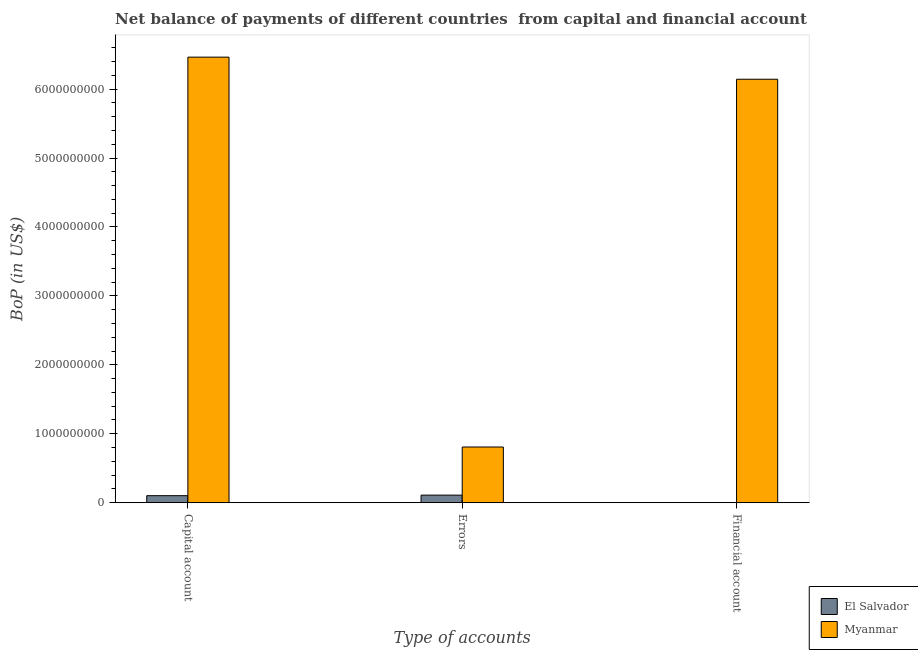Are the number of bars on each tick of the X-axis equal?
Offer a very short reply. No. How many bars are there on the 2nd tick from the left?
Offer a terse response. 2. How many bars are there on the 2nd tick from the right?
Your answer should be very brief. 2. What is the label of the 3rd group of bars from the left?
Your answer should be compact. Financial account. What is the amount of net capital account in El Salvador?
Make the answer very short. 1.01e+08. Across all countries, what is the maximum amount of errors?
Your response must be concise. 8.07e+08. Across all countries, what is the minimum amount of errors?
Make the answer very short. 1.09e+08. In which country was the amount of net capital account maximum?
Your answer should be compact. Myanmar. What is the total amount of financial account in the graph?
Your answer should be compact. 6.14e+09. What is the difference between the amount of net capital account in El Salvador and that in Myanmar?
Provide a short and direct response. -6.36e+09. What is the difference between the amount of financial account in El Salvador and the amount of errors in Myanmar?
Keep it short and to the point. -8.07e+08. What is the average amount of net capital account per country?
Keep it short and to the point. 3.28e+09. What is the difference between the amount of financial account and amount of net capital account in Myanmar?
Offer a very short reply. -3.20e+08. What is the ratio of the amount of net capital account in El Salvador to that in Myanmar?
Your answer should be very brief. 0.02. Is the amount of errors in Myanmar less than that in El Salvador?
Provide a succinct answer. No. What is the difference between the highest and the second highest amount of errors?
Give a very brief answer. 6.98e+08. What is the difference between the highest and the lowest amount of financial account?
Your response must be concise. 6.14e+09. In how many countries, is the amount of errors greater than the average amount of errors taken over all countries?
Ensure brevity in your answer.  1. Is the sum of the amount of errors in Myanmar and El Salvador greater than the maximum amount of net capital account across all countries?
Provide a succinct answer. No. Is it the case that in every country, the sum of the amount of net capital account and amount of errors is greater than the amount of financial account?
Ensure brevity in your answer.  Yes. How many bars are there?
Your response must be concise. 5. What is the difference between two consecutive major ticks on the Y-axis?
Give a very brief answer. 1.00e+09. Are the values on the major ticks of Y-axis written in scientific E-notation?
Offer a very short reply. No. Does the graph contain grids?
Offer a terse response. No. Where does the legend appear in the graph?
Your answer should be compact. Bottom right. How are the legend labels stacked?
Your answer should be compact. Vertical. What is the title of the graph?
Your answer should be compact. Net balance of payments of different countries  from capital and financial account. What is the label or title of the X-axis?
Keep it short and to the point. Type of accounts. What is the label or title of the Y-axis?
Your response must be concise. BoP (in US$). What is the BoP (in US$) in El Salvador in Capital account?
Offer a very short reply. 1.01e+08. What is the BoP (in US$) in Myanmar in Capital account?
Offer a terse response. 6.46e+09. What is the BoP (in US$) in El Salvador in Errors?
Provide a short and direct response. 1.09e+08. What is the BoP (in US$) of Myanmar in Errors?
Your answer should be very brief. 8.07e+08. What is the BoP (in US$) of Myanmar in Financial account?
Ensure brevity in your answer.  6.14e+09. Across all Type of accounts, what is the maximum BoP (in US$) of El Salvador?
Offer a very short reply. 1.09e+08. Across all Type of accounts, what is the maximum BoP (in US$) of Myanmar?
Offer a terse response. 6.46e+09. Across all Type of accounts, what is the minimum BoP (in US$) in El Salvador?
Make the answer very short. 0. Across all Type of accounts, what is the minimum BoP (in US$) of Myanmar?
Make the answer very short. 8.07e+08. What is the total BoP (in US$) in El Salvador in the graph?
Your response must be concise. 2.10e+08. What is the total BoP (in US$) of Myanmar in the graph?
Offer a terse response. 1.34e+1. What is the difference between the BoP (in US$) of El Salvador in Capital account and that in Errors?
Offer a terse response. -8.09e+06. What is the difference between the BoP (in US$) in Myanmar in Capital account and that in Errors?
Provide a short and direct response. 5.66e+09. What is the difference between the BoP (in US$) in Myanmar in Capital account and that in Financial account?
Provide a succinct answer. 3.20e+08. What is the difference between the BoP (in US$) of Myanmar in Errors and that in Financial account?
Your answer should be compact. -5.34e+09. What is the difference between the BoP (in US$) of El Salvador in Capital account and the BoP (in US$) of Myanmar in Errors?
Your answer should be very brief. -7.06e+08. What is the difference between the BoP (in US$) of El Salvador in Capital account and the BoP (in US$) of Myanmar in Financial account?
Make the answer very short. -6.04e+09. What is the difference between the BoP (in US$) of El Salvador in Errors and the BoP (in US$) of Myanmar in Financial account?
Provide a short and direct response. -6.03e+09. What is the average BoP (in US$) of El Salvador per Type of accounts?
Ensure brevity in your answer.  7.01e+07. What is the average BoP (in US$) of Myanmar per Type of accounts?
Keep it short and to the point. 4.47e+09. What is the difference between the BoP (in US$) of El Salvador and BoP (in US$) of Myanmar in Capital account?
Ensure brevity in your answer.  -6.36e+09. What is the difference between the BoP (in US$) in El Salvador and BoP (in US$) in Myanmar in Errors?
Provide a succinct answer. -6.98e+08. What is the ratio of the BoP (in US$) in El Salvador in Capital account to that in Errors?
Keep it short and to the point. 0.93. What is the ratio of the BoP (in US$) in Myanmar in Capital account to that in Errors?
Your answer should be very brief. 8.01. What is the ratio of the BoP (in US$) of Myanmar in Capital account to that in Financial account?
Your response must be concise. 1.05. What is the ratio of the BoP (in US$) of Myanmar in Errors to that in Financial account?
Offer a very short reply. 0.13. What is the difference between the highest and the second highest BoP (in US$) in Myanmar?
Offer a very short reply. 3.20e+08. What is the difference between the highest and the lowest BoP (in US$) in El Salvador?
Ensure brevity in your answer.  1.09e+08. What is the difference between the highest and the lowest BoP (in US$) in Myanmar?
Make the answer very short. 5.66e+09. 